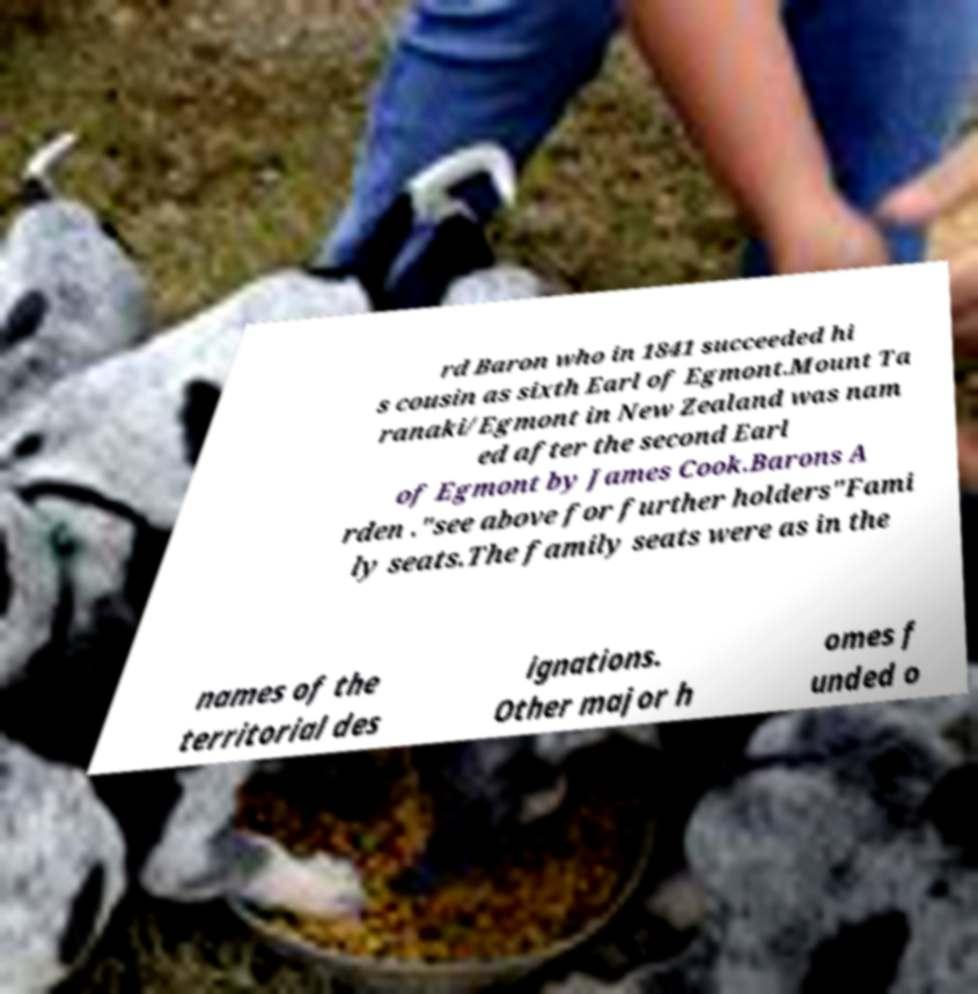Can you accurately transcribe the text from the provided image for me? rd Baron who in 1841 succeeded hi s cousin as sixth Earl of Egmont.Mount Ta ranaki/Egmont in New Zealand was nam ed after the second Earl of Egmont by James Cook.Barons A rden ."see above for further holders"Fami ly seats.The family seats were as in the names of the territorial des ignations. Other major h omes f unded o 